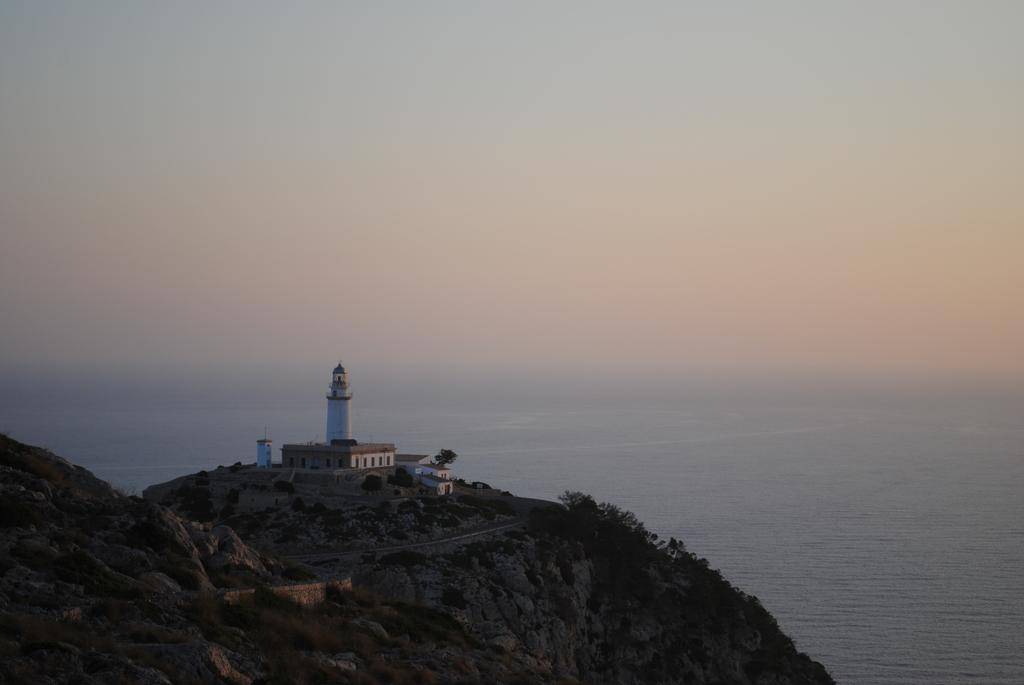What is the main structure visible in the image? There is a lighthouse in the image. What other buildings can be seen in the image? There are houses on top of a hill in the image. What natural feature is visible in the background of the image? There is a sea in the background of the image. How many stones are present in the image? There is no mention of stones in the image, so it is not possible to determine their number. 